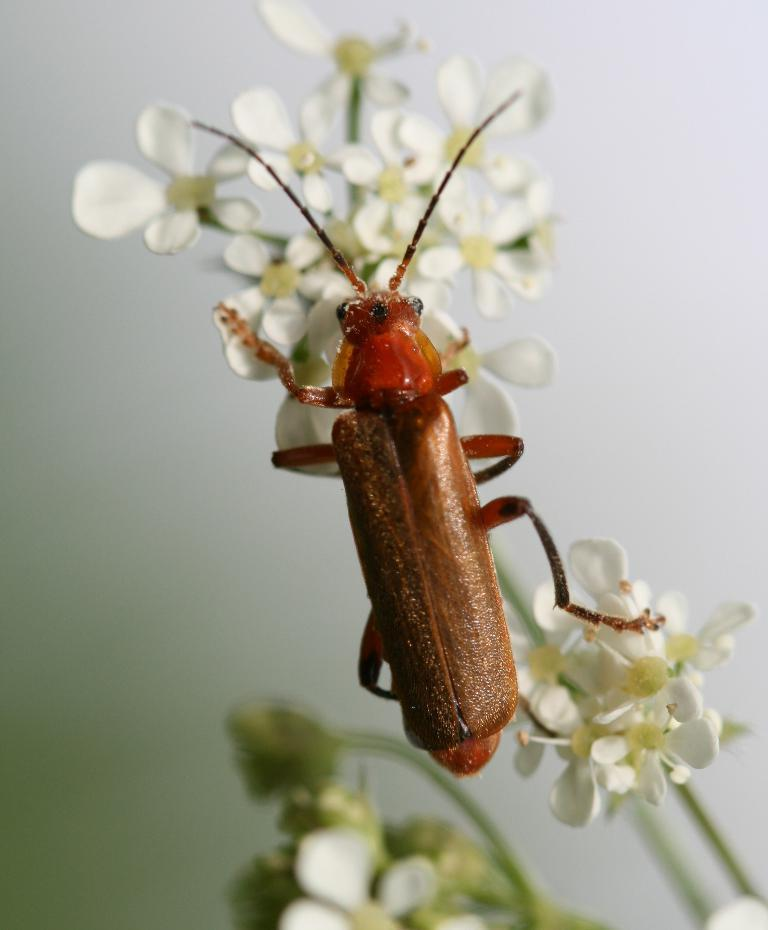What type of insect is in the image? There is a cosnards net winged beetle in the image. What is the beetle doing or resting on in the image? The beetle is on flowers in the image. What else can be seen in the image besides the beetle and flowers? There are stems visible in the image. What is the background of the image? There is a white wall in the background of the image. What type of skirt is hanging on the drawer in the image? There is no skirt or drawer present in the image; it features a cosnards net winged beetle on flowers with stems and a white wall in the background. 